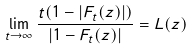<formula> <loc_0><loc_0><loc_500><loc_500>\lim _ { t \rightarrow \infty } \frac { t ( 1 - \left | F _ { t } ( z ) \right | ) } { \left | 1 - F _ { t } ( z ) \right | } = L ( z )</formula> 